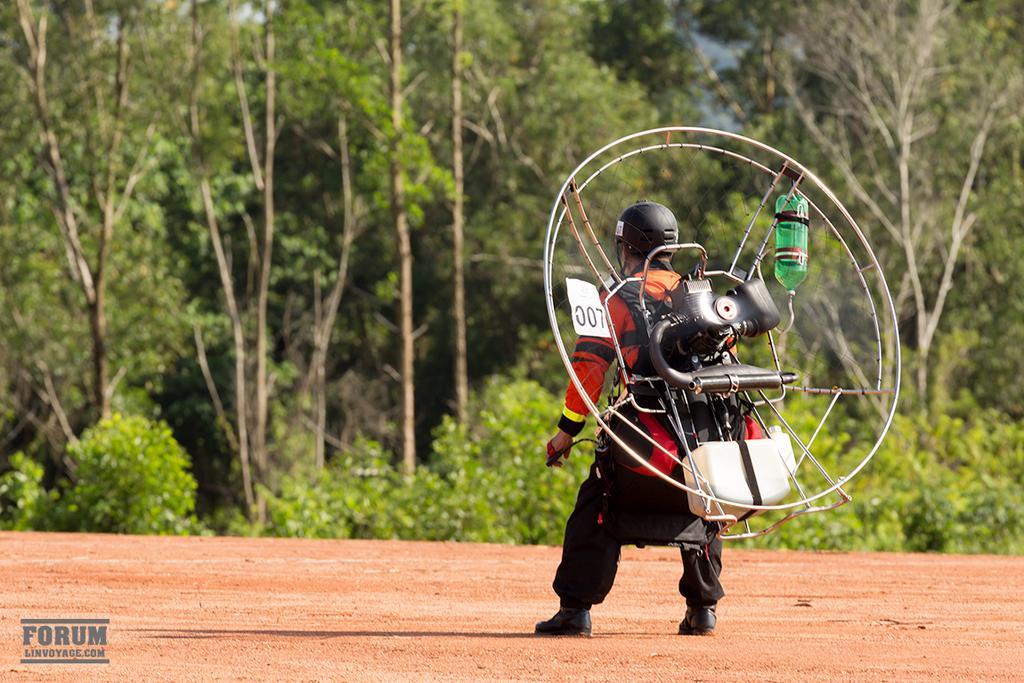Could you give a brief overview of what you see in this image? In this picture we can see a bottle, sticker, helmet, shoes, some objects and a person standing on the ground and in the background we can see trees. 